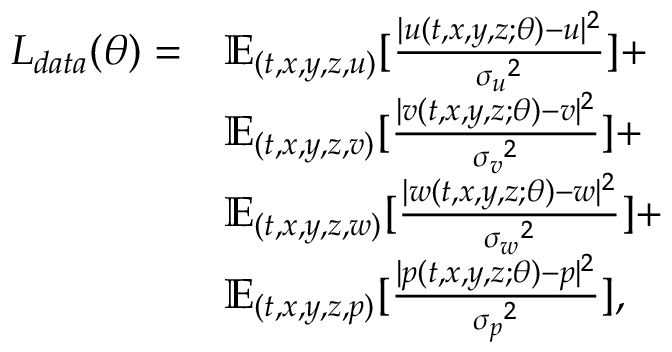Convert formula to latex. <formula><loc_0><loc_0><loc_500><loc_500>\begin{array} { r l } { L _ { d a t a } ( \theta ) = } & { \mathbb { E } _ { ( t , x , y , z , u ) } [ \frac { | { u } ( t , x , y , z ; \theta ) - { u } | ^ { 2 } } { { \sigma _ { u } } ^ { 2 } } ] + } \\ & { \mathbb { E } _ { ( t , x , y , z , v ) } [ \frac { | { v } ( t , x , y , z ; \theta ) - { v } | ^ { 2 } } { { \sigma _ { v } } ^ { 2 } } ] + } \\ & { \mathbb { E } _ { ( t , x , y , z , w ) } [ \frac { | { w } ( t , x , y , z ; \theta ) - { w } | ^ { 2 } } { { \sigma _ { w } } ^ { 2 } } ] + } \\ & { \mathbb { E } _ { ( t , x , y , z , p ) } [ \frac { | { p } ( t , x , y , z ; \theta ) - { p } | ^ { 2 } } { { \sigma _ { p } } ^ { 2 } } ] , } \end{array}</formula> 